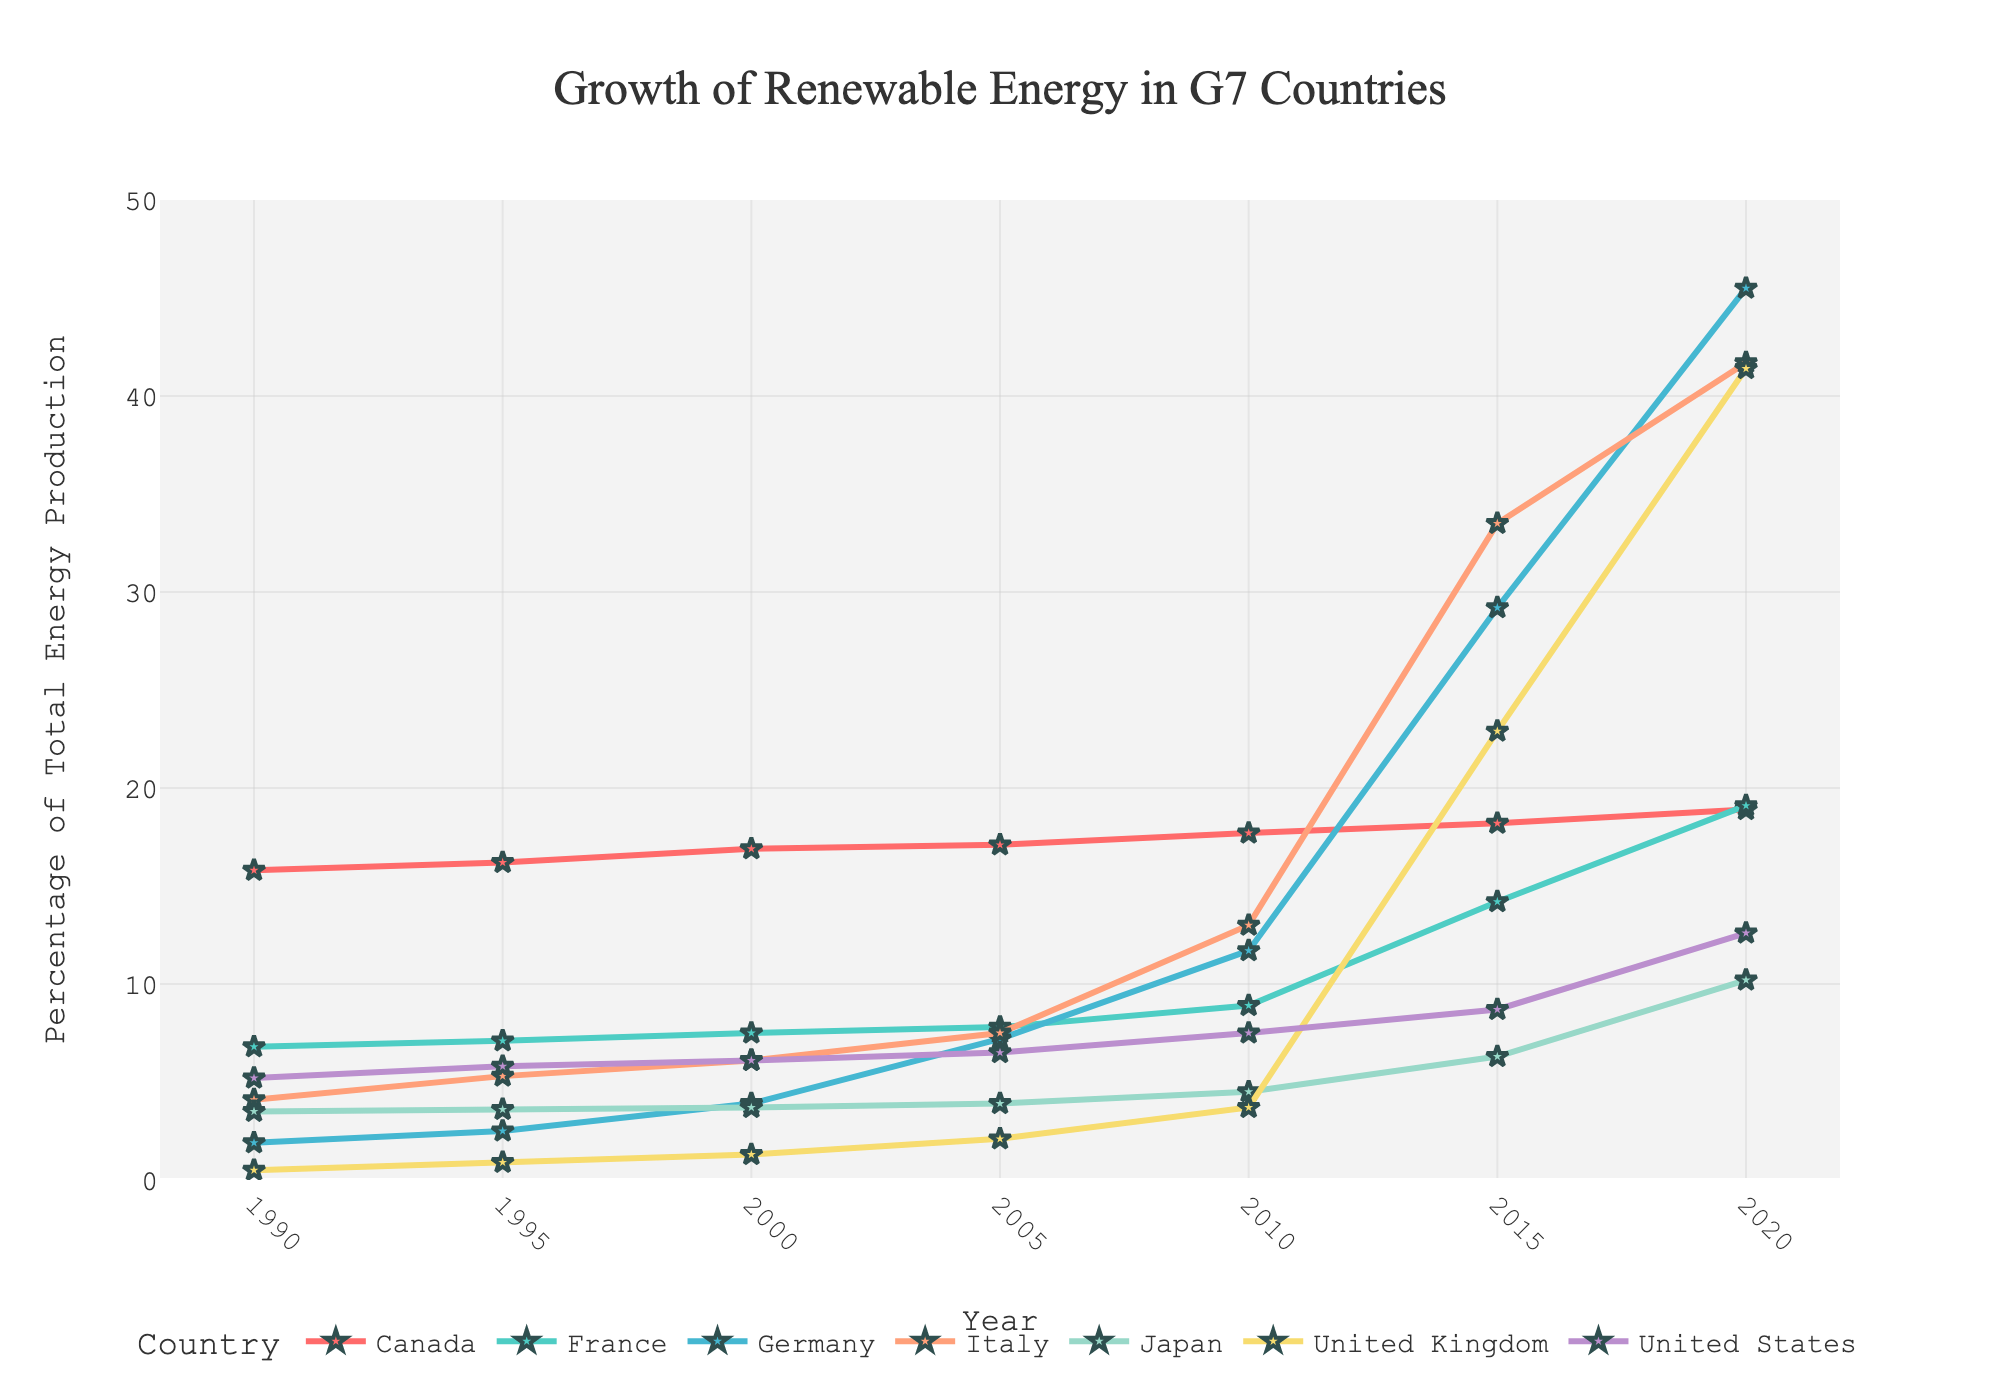Which G7 country had the highest percentage growth in renewable energy by 2020? To find this, look at the y-values for all countries in 2020 and identify the one with the largest value. Germany has the highest percentage at 45.5%.
Answer: Germany Between 1990 and 2020, which country saw the largest absolute increase in the percentage of renewable energy production? First, calculate the difference in renewable energy percentage between 2020 and 1990 for each country. The differences are: Canada (3.1), France (12.3), Germany (43.6), Italy (37.6), Japan (6.7), United Kingdom (40.9), United States (7.4). Germany has the largest absolute increase.
Answer: Germany What is the overall trend of renewable energy growth in G7 countries? Examine the trend lines for all countries from 1990 to 2020. All countries show an upward trend indicating growth in renewable energy production.
Answer: Upward trend Compare the renewable energy percentages of the United Kingdom and Italy in 2020. Which country has a higher percentage? Look at the y-values for both the United Kingdom (41.4%) and Italy (41.7%) in 2020. Italy has a slightly higher percentage.
Answer: Italy What is the average percentage of renewable energy production for France in 2000, 2010, and 2020? Add the percentages for France in these years and divide by 3. (7.5 + 8.9 + 19.1) / 3 = 35.5 / 3 = 11.83 (approx).
Answer: 11.83 How did Japan's renewable energy percentage change between 2000 and 2015? Subtract the percentage in 2000 from the percentage in 2015. (6.3 - 3.7) = 2.6.
Answer: 2.6 Which country had a renewable energy percentage lower than 10% in 1990 but over 40% in 2020? Compare the 1990 and 2020 data for all countries to identify such trends. The United Kingdom had 0.5% in 1990 and 41.4% in 2020.
Answer: United Kingdom If you average the renewable energy percentages of Canada from 1990 to 2020, what is the result? Calculate the average of all percentage values for Canada across all years. (15.8 + 16.2 + 16.9 + 17.1 + 17.7 + 18.2 + 18.9) / 7 = 120.8 / 7 = 17.26
Answer: 17.26 Which two countries had nearly identical renewable energy percentages in 2010? Compare the 2010 values for all countries and find the pair with the smallest difference. Italy had 13.0% and Japan had 13.0%, which are the same.
Answer: Italy and Japan 